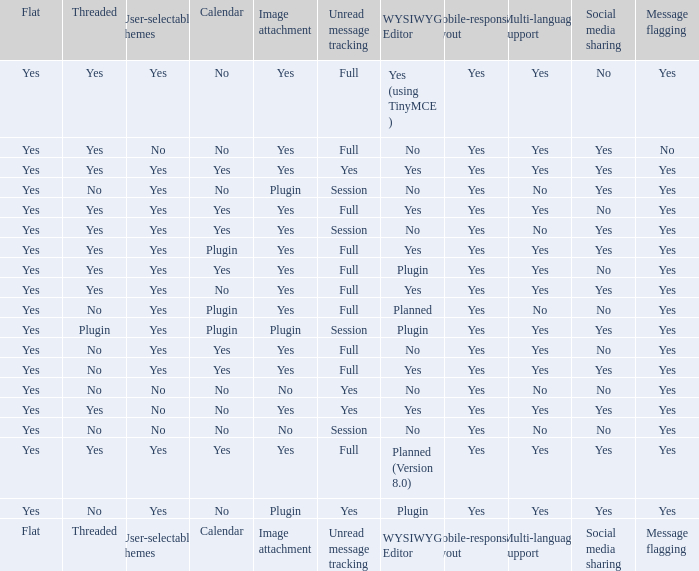Which Calendar has WYSIWYG Editor of yes and an Unread message tracking of yes? Yes, No. 